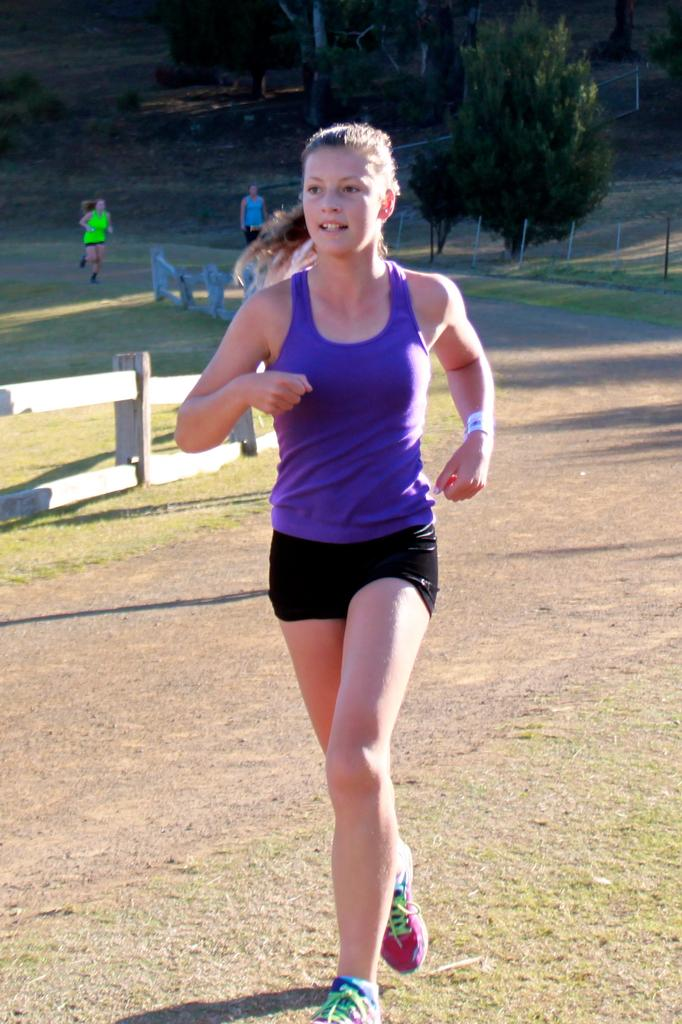What is the main action being performed by the person in the image? There is a person running on the road in the image. Are there any other people in the image? Yes, there are two other people behind the running person. What can be seen alongside the road in the image? There is a fence in the image. What is visible in the background of the image? There are trees in the background of the image. What type of unit is being measured by the children in the image? There are no children present in the image, and no units are being measured. What flavor of pie is being served to the person in the image? There is no pie present in the image. 